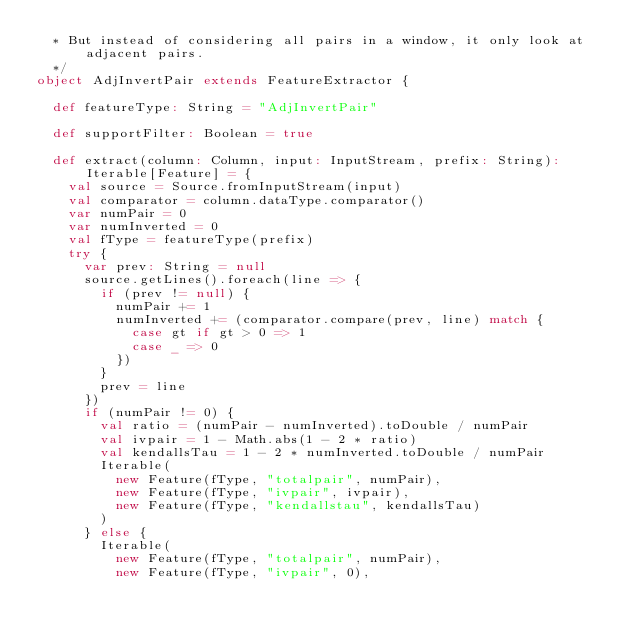Convert code to text. <code><loc_0><loc_0><loc_500><loc_500><_Scala_>  * But instead of considering all pairs in a window, it only look at adjacent pairs.
  */
object AdjInvertPair extends FeatureExtractor {

  def featureType: String = "AdjInvertPair"

  def supportFilter: Boolean = true

  def extract(column: Column, input: InputStream, prefix: String): Iterable[Feature] = {
    val source = Source.fromInputStream(input)
    val comparator = column.dataType.comparator()
    var numPair = 0
    var numInverted = 0
    val fType = featureType(prefix)
    try {
      var prev: String = null
      source.getLines().foreach(line => {
        if (prev != null) {
          numPair += 1
          numInverted += (comparator.compare(prev, line) match {
            case gt if gt > 0 => 1
            case _ => 0
          })
        }
        prev = line
      })
      if (numPair != 0) {
        val ratio = (numPair - numInverted).toDouble / numPair
        val ivpair = 1 - Math.abs(1 - 2 * ratio)
        val kendallsTau = 1 - 2 * numInverted.toDouble / numPair
        Iterable(
          new Feature(fType, "totalpair", numPair),
          new Feature(fType, "ivpair", ivpair),
          new Feature(fType, "kendallstau", kendallsTau)
        )
      } else {
        Iterable(
          new Feature(fType, "totalpair", numPair),
          new Feature(fType, "ivpair", 0),</code> 